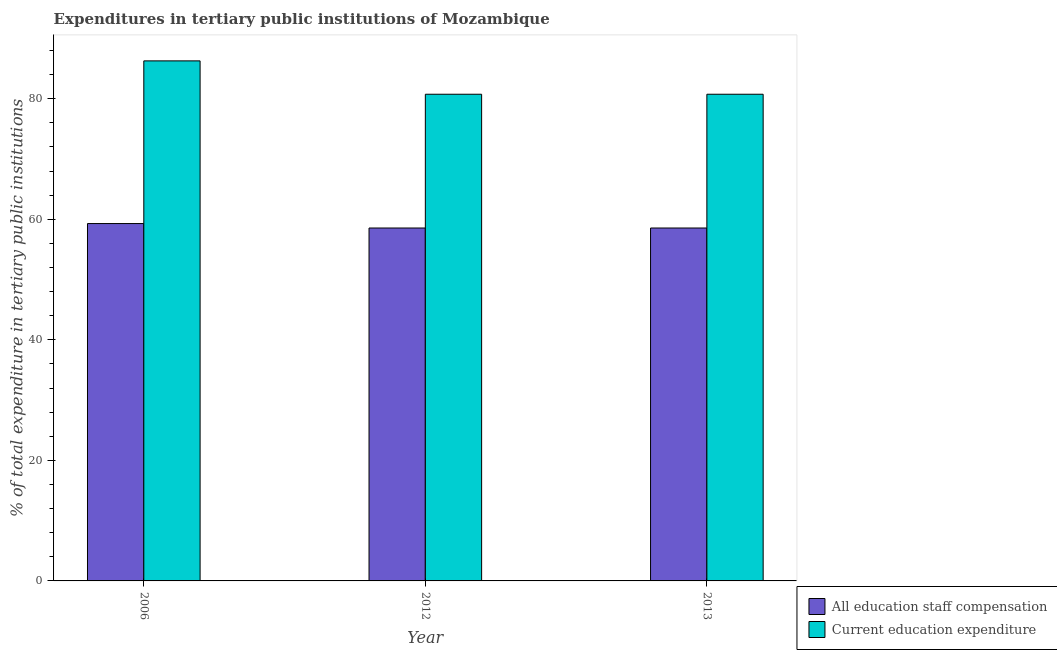What is the label of the 3rd group of bars from the left?
Your answer should be compact. 2013. What is the expenditure in staff compensation in 2006?
Make the answer very short. 59.29. Across all years, what is the maximum expenditure in staff compensation?
Your response must be concise. 59.29. Across all years, what is the minimum expenditure in education?
Your answer should be compact. 80.74. In which year was the expenditure in education maximum?
Keep it short and to the point. 2006. In which year was the expenditure in education minimum?
Provide a succinct answer. 2012. What is the total expenditure in education in the graph?
Your answer should be very brief. 247.76. What is the difference between the expenditure in education in 2012 and the expenditure in staff compensation in 2006?
Your response must be concise. -5.53. What is the average expenditure in education per year?
Ensure brevity in your answer.  82.59. What is the ratio of the expenditure in education in 2006 to that in 2013?
Keep it short and to the point. 1.07. Is the difference between the expenditure in staff compensation in 2006 and 2012 greater than the difference between the expenditure in education in 2006 and 2012?
Your answer should be very brief. No. What is the difference between the highest and the second highest expenditure in staff compensation?
Your answer should be compact. 0.74. What is the difference between the highest and the lowest expenditure in education?
Provide a succinct answer. 5.53. Is the sum of the expenditure in staff compensation in 2006 and 2012 greater than the maximum expenditure in education across all years?
Your answer should be compact. Yes. What does the 1st bar from the left in 2006 represents?
Make the answer very short. All education staff compensation. What does the 1st bar from the right in 2006 represents?
Make the answer very short. Current education expenditure. How many years are there in the graph?
Offer a terse response. 3. Are the values on the major ticks of Y-axis written in scientific E-notation?
Your answer should be very brief. No. Does the graph contain any zero values?
Ensure brevity in your answer.  No. What is the title of the graph?
Give a very brief answer. Expenditures in tertiary public institutions of Mozambique. What is the label or title of the Y-axis?
Offer a terse response. % of total expenditure in tertiary public institutions. What is the % of total expenditure in tertiary public institutions in All education staff compensation in 2006?
Provide a short and direct response. 59.29. What is the % of total expenditure in tertiary public institutions in Current education expenditure in 2006?
Ensure brevity in your answer.  86.28. What is the % of total expenditure in tertiary public institutions of All education staff compensation in 2012?
Keep it short and to the point. 58.55. What is the % of total expenditure in tertiary public institutions of Current education expenditure in 2012?
Offer a terse response. 80.74. What is the % of total expenditure in tertiary public institutions of All education staff compensation in 2013?
Your answer should be compact. 58.55. What is the % of total expenditure in tertiary public institutions in Current education expenditure in 2013?
Offer a terse response. 80.74. Across all years, what is the maximum % of total expenditure in tertiary public institutions in All education staff compensation?
Your answer should be compact. 59.29. Across all years, what is the maximum % of total expenditure in tertiary public institutions in Current education expenditure?
Ensure brevity in your answer.  86.28. Across all years, what is the minimum % of total expenditure in tertiary public institutions of All education staff compensation?
Provide a short and direct response. 58.55. Across all years, what is the minimum % of total expenditure in tertiary public institutions in Current education expenditure?
Offer a terse response. 80.74. What is the total % of total expenditure in tertiary public institutions in All education staff compensation in the graph?
Provide a succinct answer. 176.38. What is the total % of total expenditure in tertiary public institutions in Current education expenditure in the graph?
Your answer should be very brief. 247.76. What is the difference between the % of total expenditure in tertiary public institutions in All education staff compensation in 2006 and that in 2012?
Your response must be concise. 0.74. What is the difference between the % of total expenditure in tertiary public institutions of Current education expenditure in 2006 and that in 2012?
Your answer should be very brief. 5.53. What is the difference between the % of total expenditure in tertiary public institutions in All education staff compensation in 2006 and that in 2013?
Provide a succinct answer. 0.74. What is the difference between the % of total expenditure in tertiary public institutions of Current education expenditure in 2006 and that in 2013?
Provide a short and direct response. 5.53. What is the difference between the % of total expenditure in tertiary public institutions of All education staff compensation in 2012 and that in 2013?
Provide a short and direct response. 0. What is the difference between the % of total expenditure in tertiary public institutions of Current education expenditure in 2012 and that in 2013?
Make the answer very short. 0. What is the difference between the % of total expenditure in tertiary public institutions of All education staff compensation in 2006 and the % of total expenditure in tertiary public institutions of Current education expenditure in 2012?
Offer a terse response. -21.45. What is the difference between the % of total expenditure in tertiary public institutions of All education staff compensation in 2006 and the % of total expenditure in tertiary public institutions of Current education expenditure in 2013?
Provide a short and direct response. -21.45. What is the difference between the % of total expenditure in tertiary public institutions of All education staff compensation in 2012 and the % of total expenditure in tertiary public institutions of Current education expenditure in 2013?
Provide a short and direct response. -22.19. What is the average % of total expenditure in tertiary public institutions of All education staff compensation per year?
Keep it short and to the point. 58.79. What is the average % of total expenditure in tertiary public institutions of Current education expenditure per year?
Give a very brief answer. 82.59. In the year 2006, what is the difference between the % of total expenditure in tertiary public institutions in All education staff compensation and % of total expenditure in tertiary public institutions in Current education expenditure?
Your response must be concise. -26.99. In the year 2012, what is the difference between the % of total expenditure in tertiary public institutions in All education staff compensation and % of total expenditure in tertiary public institutions in Current education expenditure?
Make the answer very short. -22.19. In the year 2013, what is the difference between the % of total expenditure in tertiary public institutions of All education staff compensation and % of total expenditure in tertiary public institutions of Current education expenditure?
Provide a short and direct response. -22.19. What is the ratio of the % of total expenditure in tertiary public institutions in All education staff compensation in 2006 to that in 2012?
Offer a very short reply. 1.01. What is the ratio of the % of total expenditure in tertiary public institutions in Current education expenditure in 2006 to that in 2012?
Make the answer very short. 1.07. What is the ratio of the % of total expenditure in tertiary public institutions in All education staff compensation in 2006 to that in 2013?
Offer a very short reply. 1.01. What is the ratio of the % of total expenditure in tertiary public institutions in Current education expenditure in 2006 to that in 2013?
Offer a terse response. 1.07. What is the ratio of the % of total expenditure in tertiary public institutions of Current education expenditure in 2012 to that in 2013?
Offer a terse response. 1. What is the difference between the highest and the second highest % of total expenditure in tertiary public institutions of All education staff compensation?
Your answer should be very brief. 0.74. What is the difference between the highest and the second highest % of total expenditure in tertiary public institutions in Current education expenditure?
Provide a short and direct response. 5.53. What is the difference between the highest and the lowest % of total expenditure in tertiary public institutions in All education staff compensation?
Ensure brevity in your answer.  0.74. What is the difference between the highest and the lowest % of total expenditure in tertiary public institutions of Current education expenditure?
Ensure brevity in your answer.  5.53. 